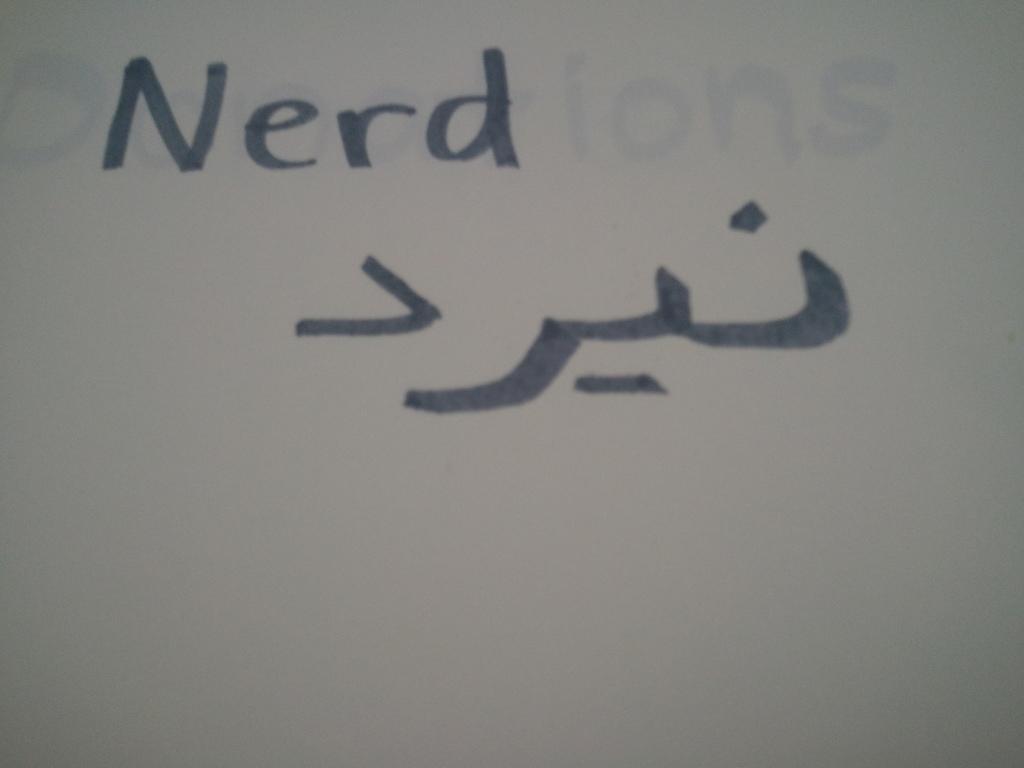What is the likely meaning of the foreign characters?
Give a very brief answer. Nerd. 